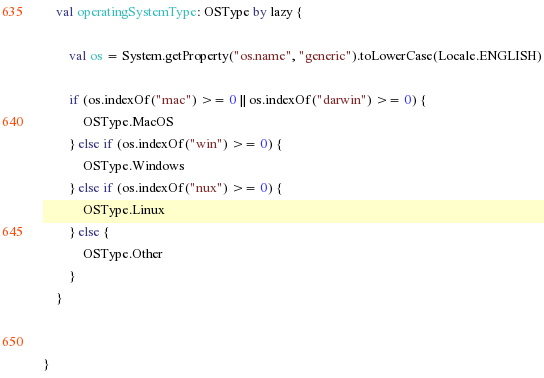Convert code to text. <code><loc_0><loc_0><loc_500><loc_500><_Kotlin_>    val operatingSystemType: OSType by lazy {

        val os = System.getProperty("os.name", "generic").toLowerCase(Locale.ENGLISH)

        if (os.indexOf("mac") >= 0 || os.indexOf("darwin") >= 0) {
            OSType.MacOS
        } else if (os.indexOf("win") >= 0) {
            OSType.Windows
        } else if (os.indexOf("nux") >= 0) {
            OSType.Linux
        } else {
            OSType.Other
        }
    }


}</code> 